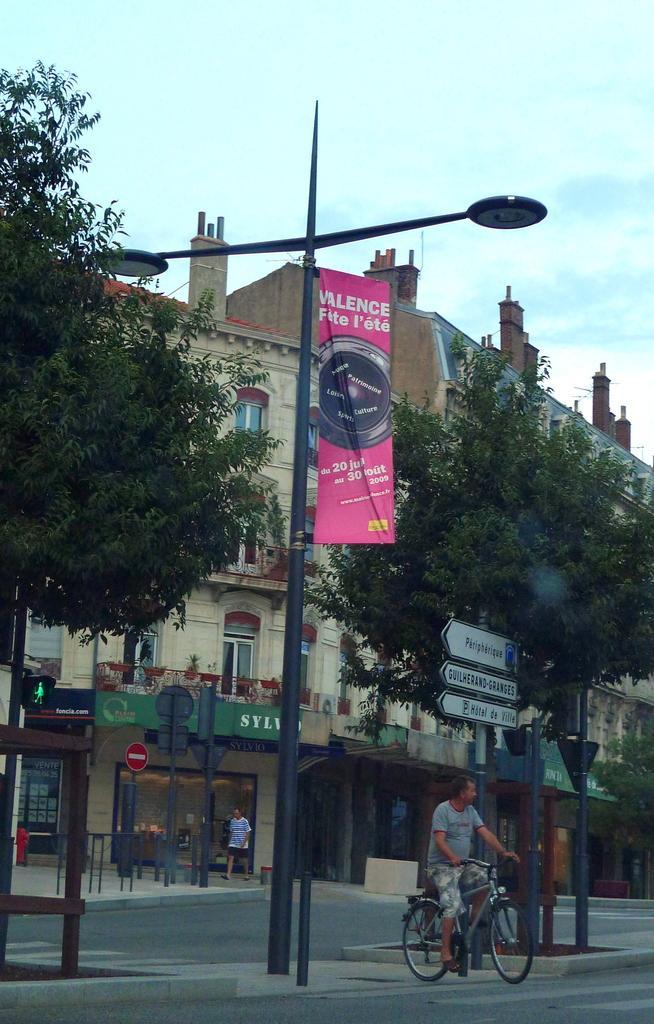Describe this image in one or two sentences. In this image I can see the person riding the bicycle. On both sides of the person I can see the boards and poles. In the background I can see the trees, one more person and the building with windows. I can also see the sky in the back. 